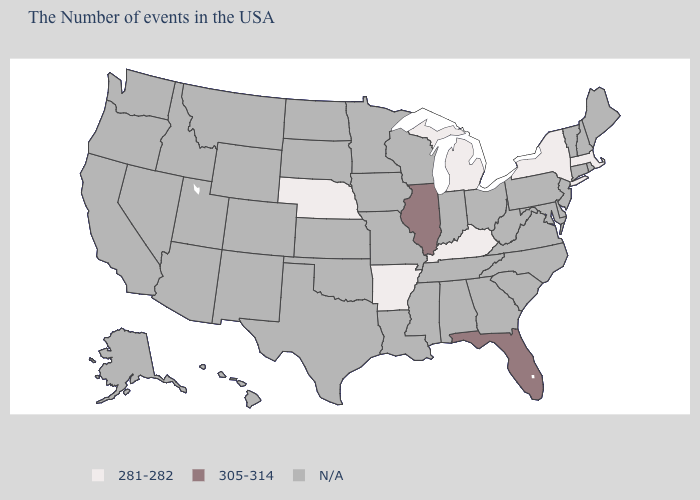Which states have the lowest value in the South?
Concise answer only. Kentucky, Arkansas. What is the highest value in states that border West Virginia?
Quick response, please. 281-282. What is the value of Connecticut?
Give a very brief answer. N/A. Name the states that have a value in the range 281-282?
Answer briefly. Massachusetts, New York, Michigan, Kentucky, Arkansas, Nebraska. Name the states that have a value in the range N/A?
Answer briefly. Maine, Rhode Island, New Hampshire, Vermont, Connecticut, New Jersey, Delaware, Maryland, Pennsylvania, Virginia, North Carolina, South Carolina, West Virginia, Ohio, Georgia, Indiana, Alabama, Tennessee, Wisconsin, Mississippi, Louisiana, Missouri, Minnesota, Iowa, Kansas, Oklahoma, Texas, South Dakota, North Dakota, Wyoming, Colorado, New Mexico, Utah, Montana, Arizona, Idaho, Nevada, California, Washington, Oregon, Alaska, Hawaii. Is the legend a continuous bar?
Give a very brief answer. No. What is the value of Indiana?
Quick response, please. N/A. What is the value of Washington?
Concise answer only. N/A. Name the states that have a value in the range 305-314?
Concise answer only. Florida, Illinois. What is the highest value in states that border West Virginia?
Keep it brief. 281-282. Which states have the highest value in the USA?
Short answer required. Florida, Illinois. Does the first symbol in the legend represent the smallest category?
Quick response, please. Yes. Name the states that have a value in the range 281-282?
Give a very brief answer. Massachusetts, New York, Michigan, Kentucky, Arkansas, Nebraska. Does Massachusetts have the lowest value in the USA?
Write a very short answer. Yes. Does the first symbol in the legend represent the smallest category?
Concise answer only. Yes. 